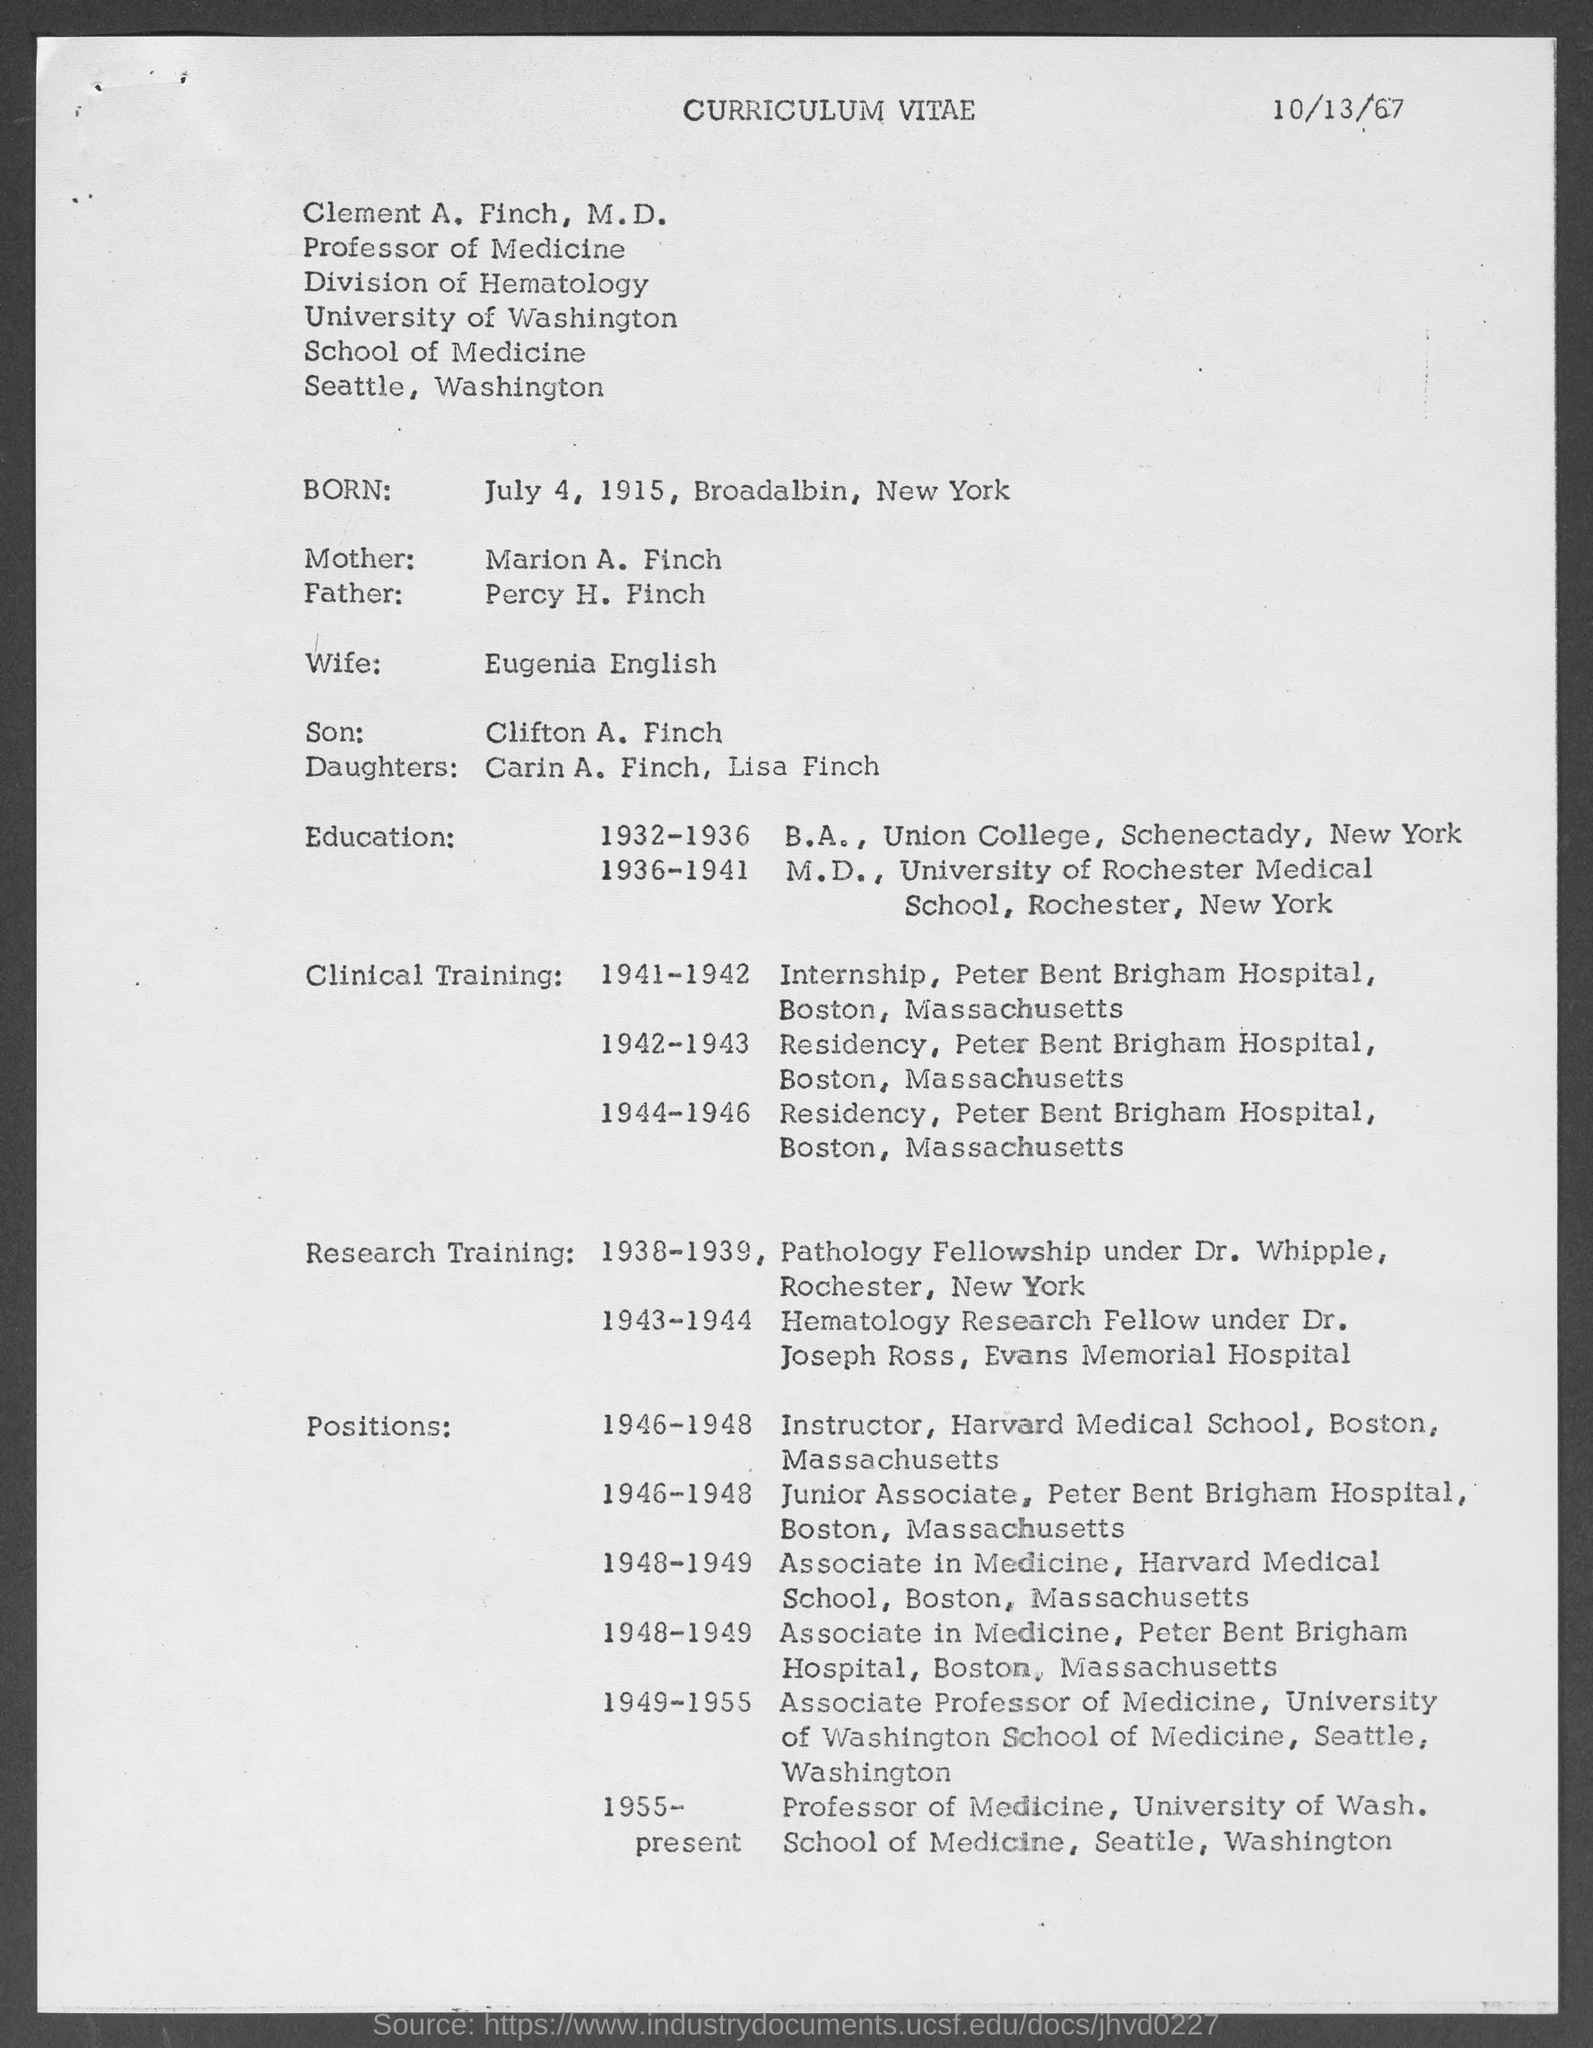Give some essential details in this illustration. Clement completed his internship in 1941-1942. Clement A. Finch holds the designation of Professor of Medicine. Clement is married to Eugenia English. The name of Clement's son is Clifton A. Finch. The document was dated on October 13, 1967. 